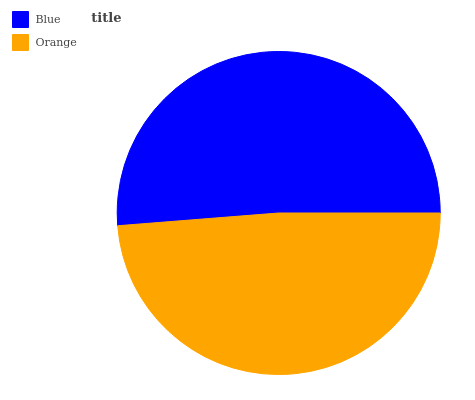Is Orange the minimum?
Answer yes or no. Yes. Is Blue the maximum?
Answer yes or no. Yes. Is Orange the maximum?
Answer yes or no. No. Is Blue greater than Orange?
Answer yes or no. Yes. Is Orange less than Blue?
Answer yes or no. Yes. Is Orange greater than Blue?
Answer yes or no. No. Is Blue less than Orange?
Answer yes or no. No. Is Blue the high median?
Answer yes or no. Yes. Is Orange the low median?
Answer yes or no. Yes. Is Orange the high median?
Answer yes or no. No. Is Blue the low median?
Answer yes or no. No. 